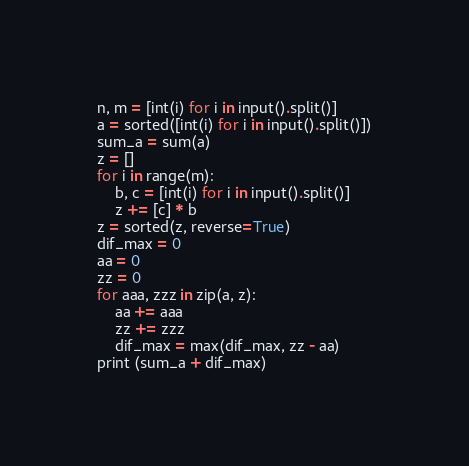Convert code to text. <code><loc_0><loc_0><loc_500><loc_500><_Python_>n, m = [int(i) for i in input().split()]
a = sorted([int(i) for i in input().split()])
sum_a = sum(a)
z = []
for i in range(m):
	b, c = [int(i) for i in input().split()]
	z += [c] * b
z = sorted(z, reverse=True)
dif_max = 0
aa = 0
zz = 0
for aaa, zzz in zip(a, z):
	aa += aaa
	zz += zzz
	dif_max = max(dif_max, zz - aa)
print (sum_a + dif_max)</code> 